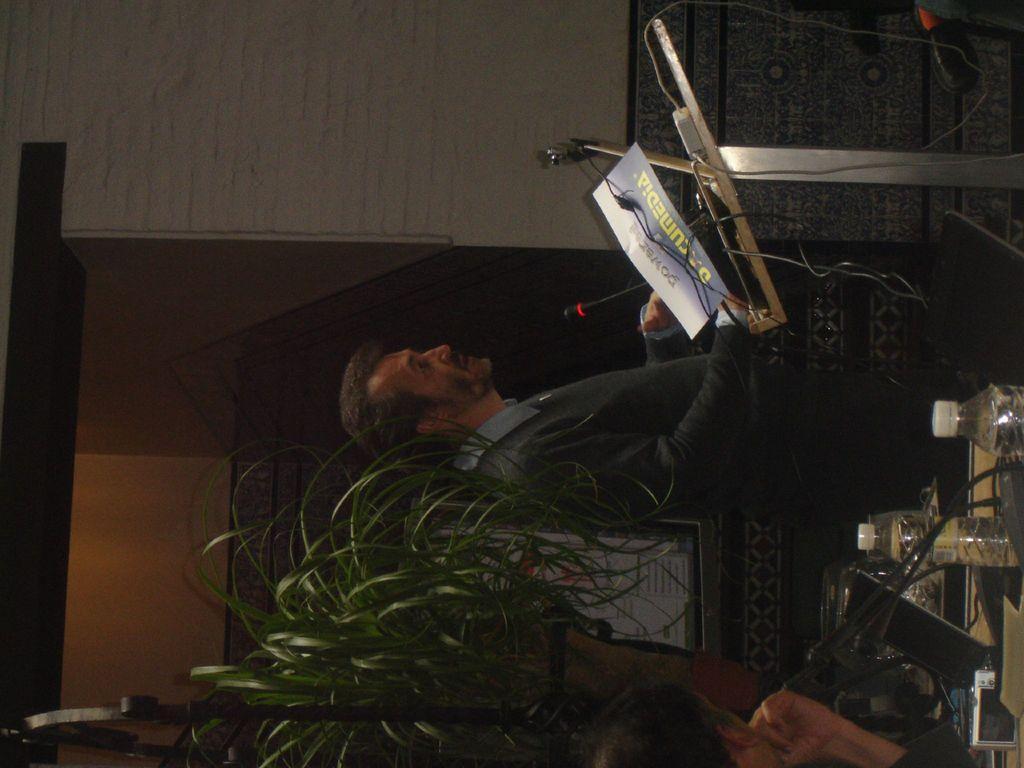Please provide a concise description of this image. This picture shows a man standing and speaking with the help of a microphone and we see a paper and a plant on the back and we see another man seated and we see water bottles and a microphone on the table. 